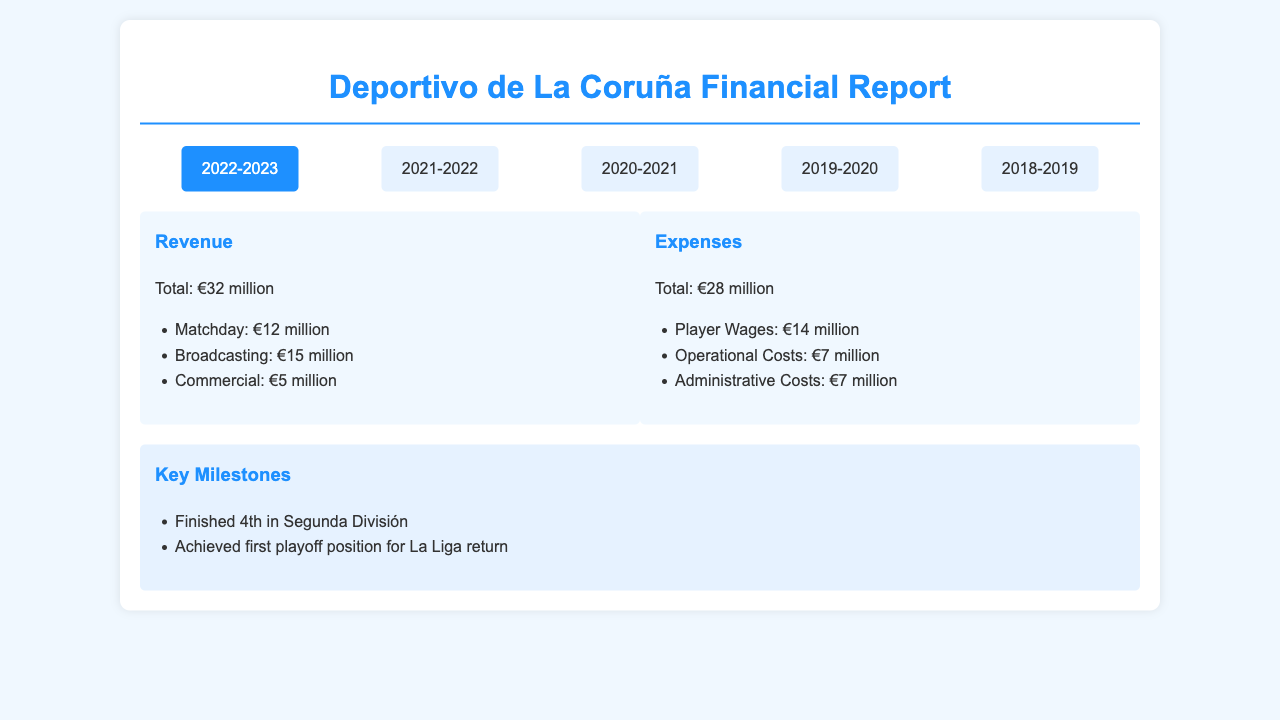What was Deportivo de La Coruña's revenue in 2022-2023? The revenue for the 2022-2023 season is detailed in the document, stating a total of €32 million.
Answer: €32 million What were the player wages in 2019-2020? The player wages for the 2019-2020 season are specifically listed in the expenses section as €19 million.
Answer: €19 million What key milestone did Deportivo achieve in 2022-2023? The document lists a key milestone for the 2022-2023 season as finishing 4th in Segunda División.
Answer: Finished 4th in Segunda División What was the total expense for the 2020-2021 season? The document provides the total expenses for the 2020-2021 season as €25 million.
Answer: €25 million Which season saw the highest total revenue? The document shows that 2022-2023 had the highest total revenue of €32 million compared to all other listed seasons.
Answer: 2022-2023 How much did Deportivo de La Coruña spend on operational costs in 2021-2022? The operational costs for 2021-2022 are enumerated in the expenses section, which is €8 million.
Answer: €8 million What was the total revenue in 2018-2019? According to the document, the total revenue for the 2018-2019 season is €30 million.
Answer: €30 million What key milestone did Deportivo reach in 2021-2022? The year 2021-2022 includes a significant milestone of gaining promotion to Segunda División.
Answer: Promotion to Segunda División gained How much did Deportivo earn from matchday revenues in 2020-2021? The matchday revenue in 2020-2021 season is clearly stated to be €2 million.
Answer: €2 million 